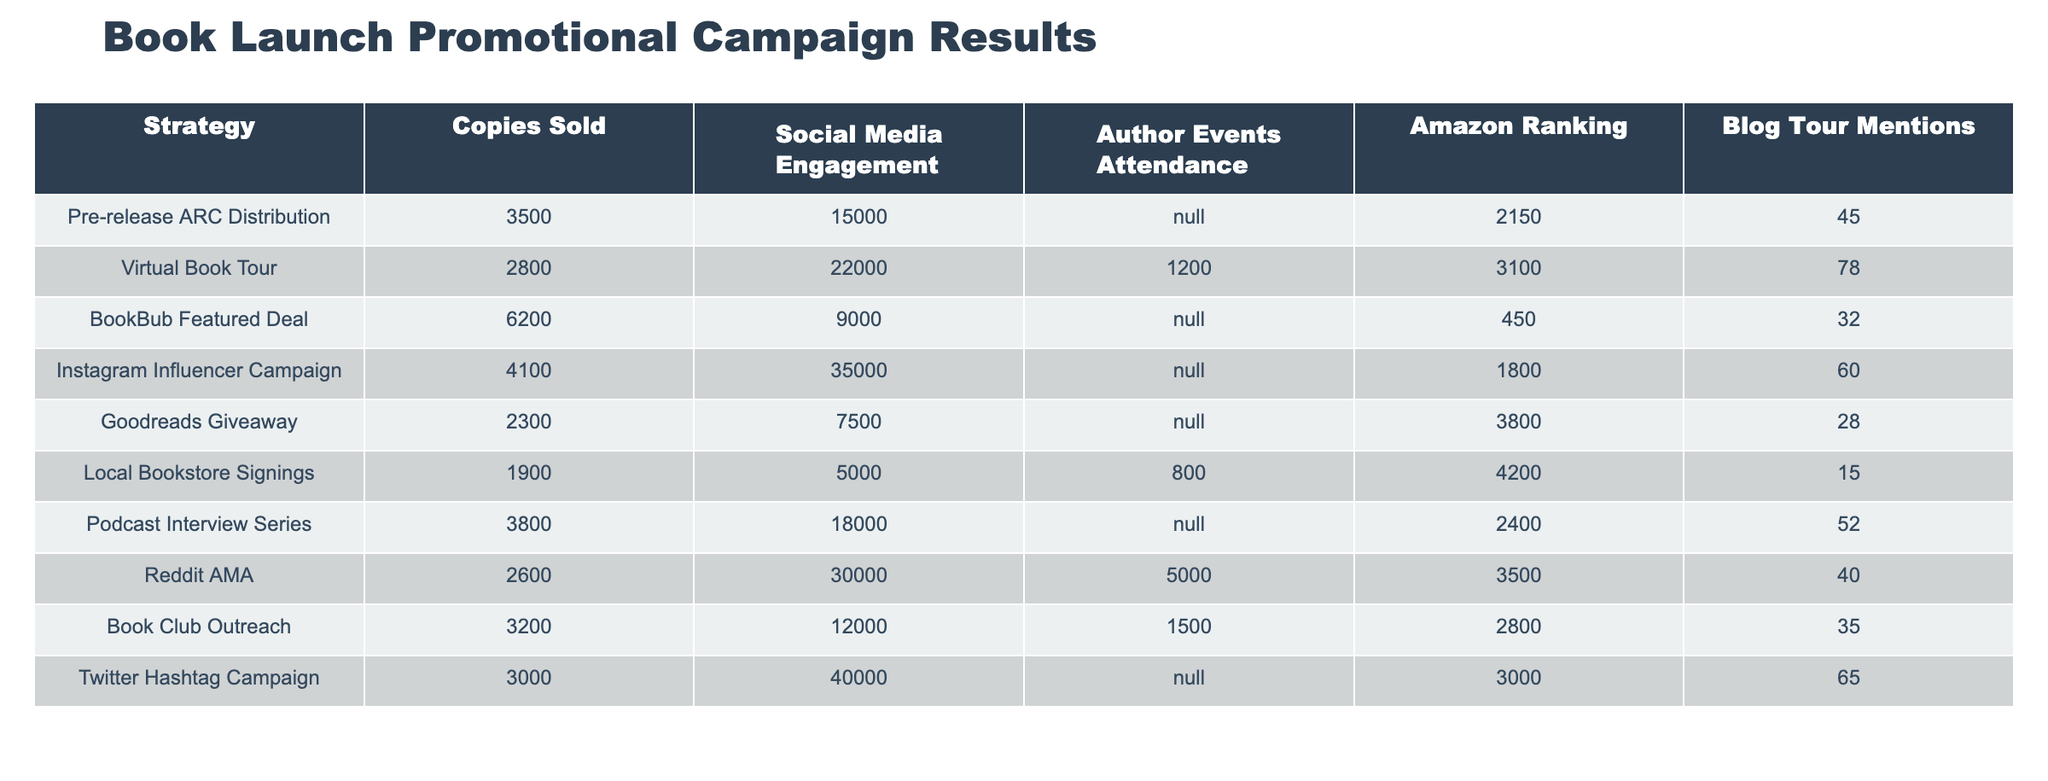What strategy resulted in the highest number of copies sold? The highest number of copies sold is from the BookBub Featured Deal, which sold 6200 copies. I identified this by comparing the "Copies Sold" column for all strategies.
Answer: BookBub Featured Deal Which strategy had the lowest Amazon ranking? The Local Bookstore Signings had the lowest Amazon ranking of 4200. I found this by looking for the maximum value in the "Amazon Ranking" column and identifying the strategy associated with it.
Answer: Local Bookstore Signings How many copies were sold in total across all strategies? To find the total copies sold, I added all the values from the "Copies Sold" column: 3500 + 2800 + 6200 + 4100 + 2300 + 1900 + 3800 + 2600 + 3200 + 3000 = 28700.
Answer: 28700 What is the average social media engagement for the strategies listed? To calculate the average engagement, I summed the engagement values (15000 + 22000 + 9000 + 35000 + 7500 + 5000 + 18000 + 30000 + 12000 + 40000 = 207500) and divided by the number of strategies (10), which gives an average of 20750.
Answer: 20750 Did the Instagram Influencer Campaign lead to more social media engagement than the Virtual Book Tour? Yes, the Instagram Influencer Campaign had an engagement of 35000, which is more than the Virtual Book Tour's engagement of 22000. I compared the values in the "Social Media Engagement" column for both strategies.
Answer: Yes Which strategy had a better outcome in terms of both copies sold and social media engagement: Reddit AMA or Podcast Interview Series? For the Reddit AMA, there were 2600 copies sold and 30000 in engagement. For the Podcast Interview Series, there were 3800 copies sold and 18000 in engagement. While the Podcast Interview Series had more copies sold, the Reddit AMA had higher engagement. To determine which was better overall, I evaluated both dimensions and concluded that the Podcast Interview Series was better in copies sold, but Reddit AMA excelled in engagement.
Answer: Podcast Interview Series (more copies sold), Reddit AMA (more engagement) Is there any strategy that achieved more than 5000 in author events attendance? No, according to the data provided, the highest attendance in author events was 800 for Local Bookstore Signings, which is below 5000. I reviewed the "Author Events Attendance" column to check for any values greater than 5000.
Answer: No What is the difference in blog tour mentions between the Book Club Outreach and Local Bookstore Signings? The Blog Club Outreach had 35 mentions while the Local Bookstore Signings had 15 mentions. The difference is 35 - 15 = 20. I simply subtracted the values in the "Blog Tour Mentions" column for these two strategies.
Answer: 20 